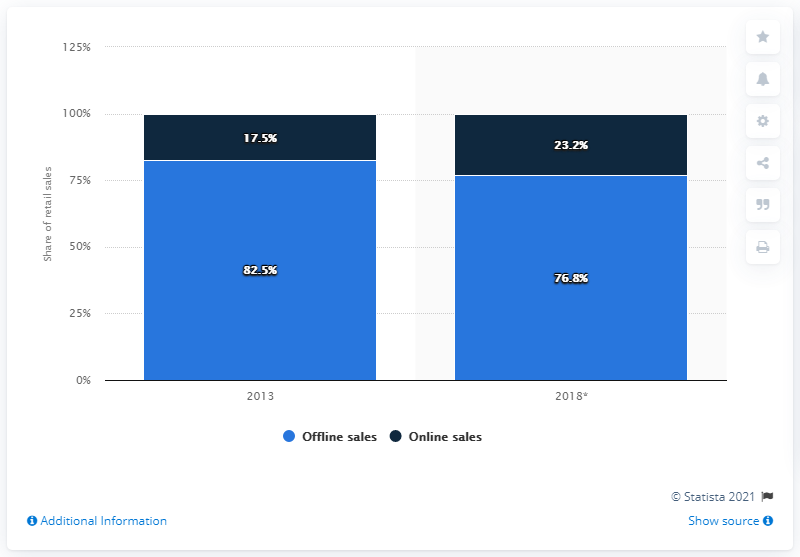Give some essential details in this illustration. By 2018, online sales of electricals and electronics are predicted to increase by 23.2%. In 2013, online sales accounted for 17.5% of electricals and electronics sales in Germany. 